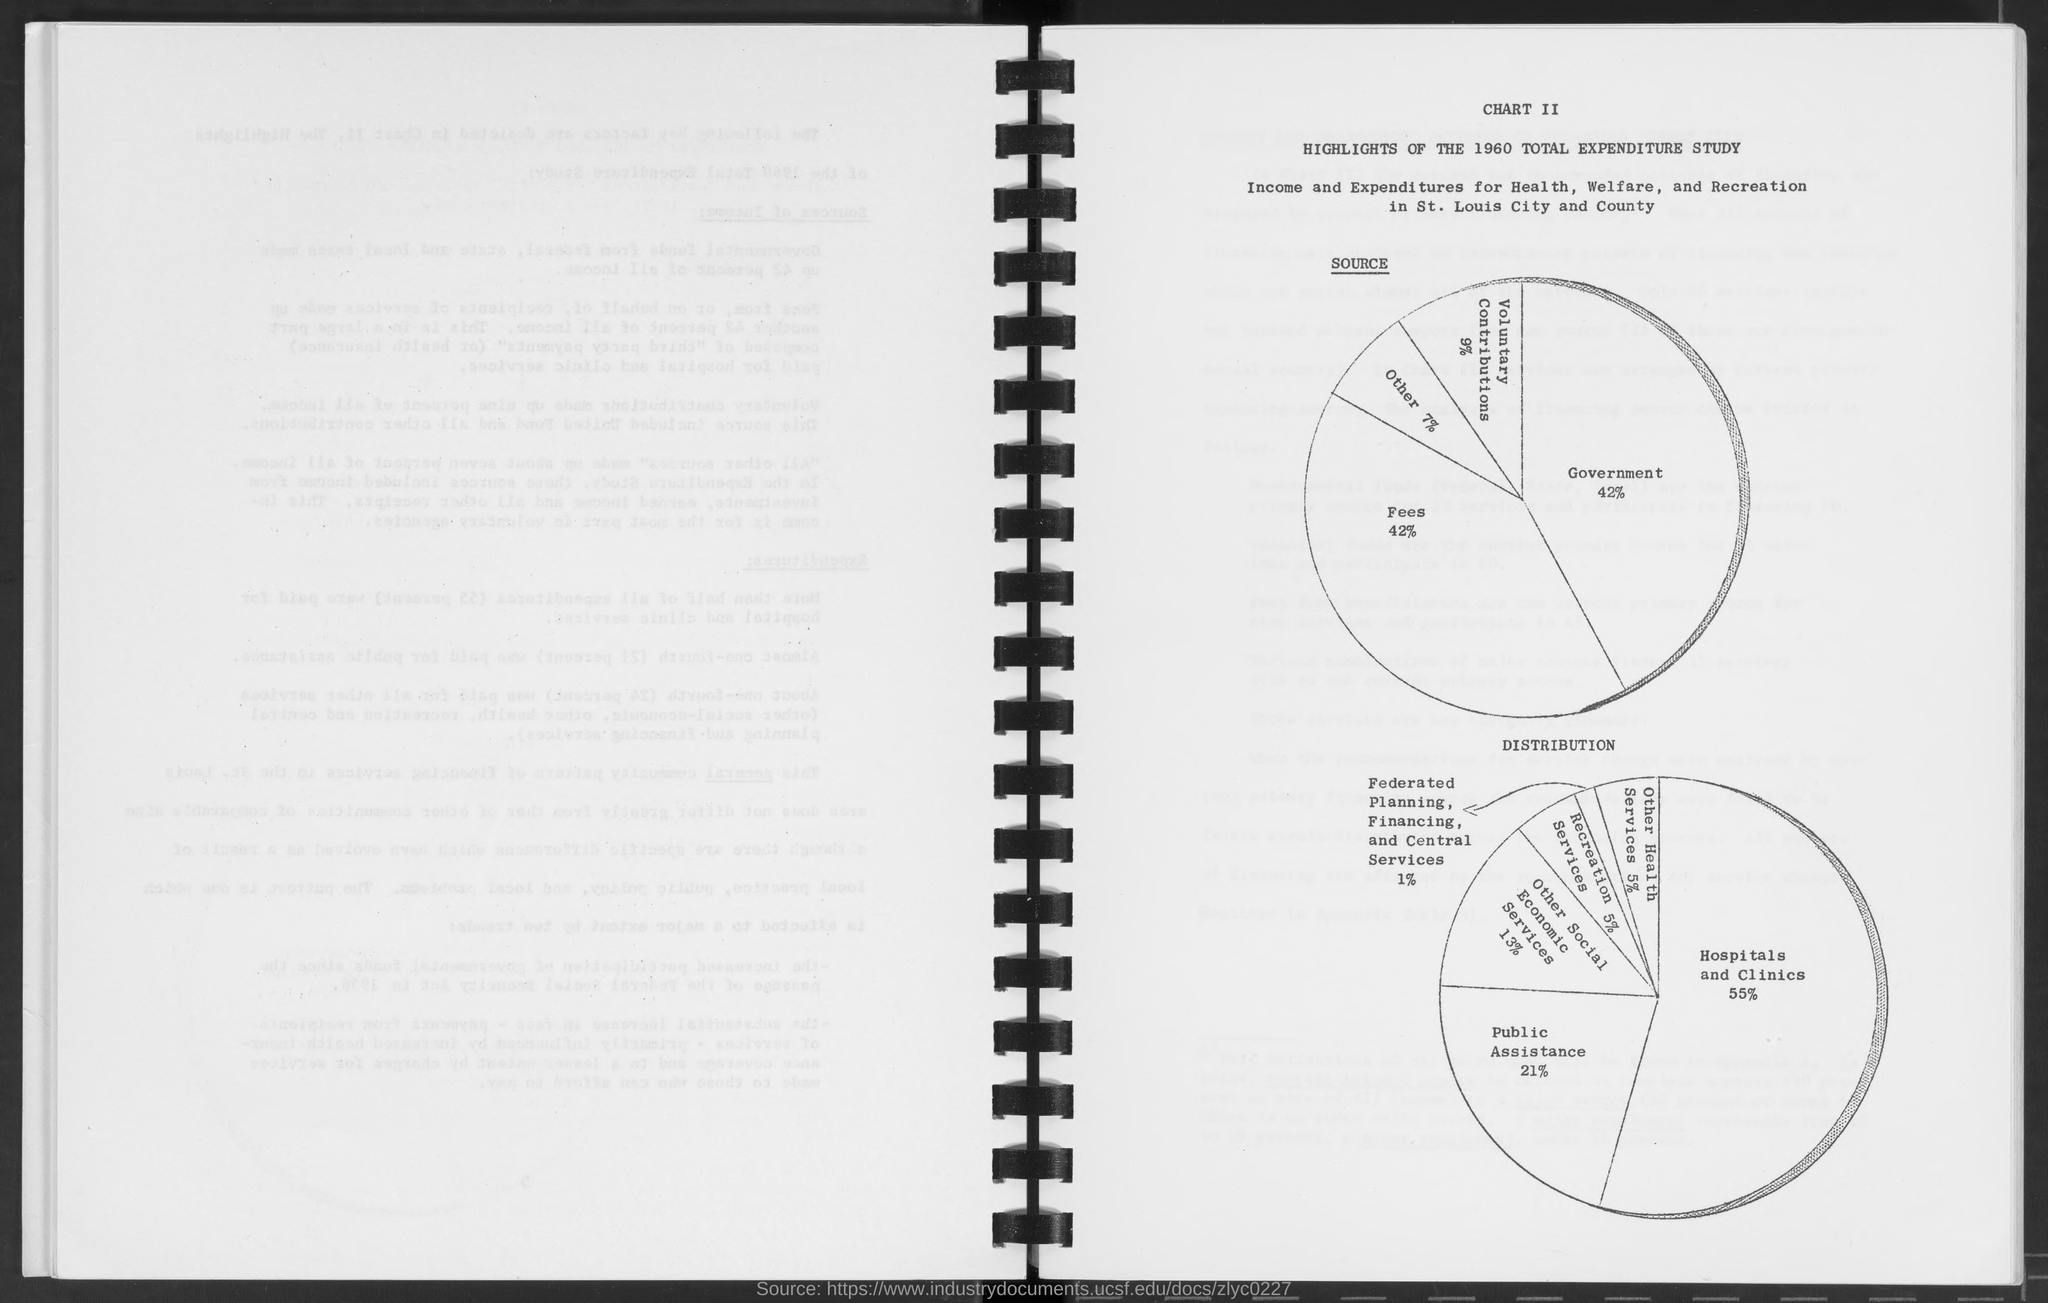what is the percentage for government in source as mentioned in the given page ?
 42% 